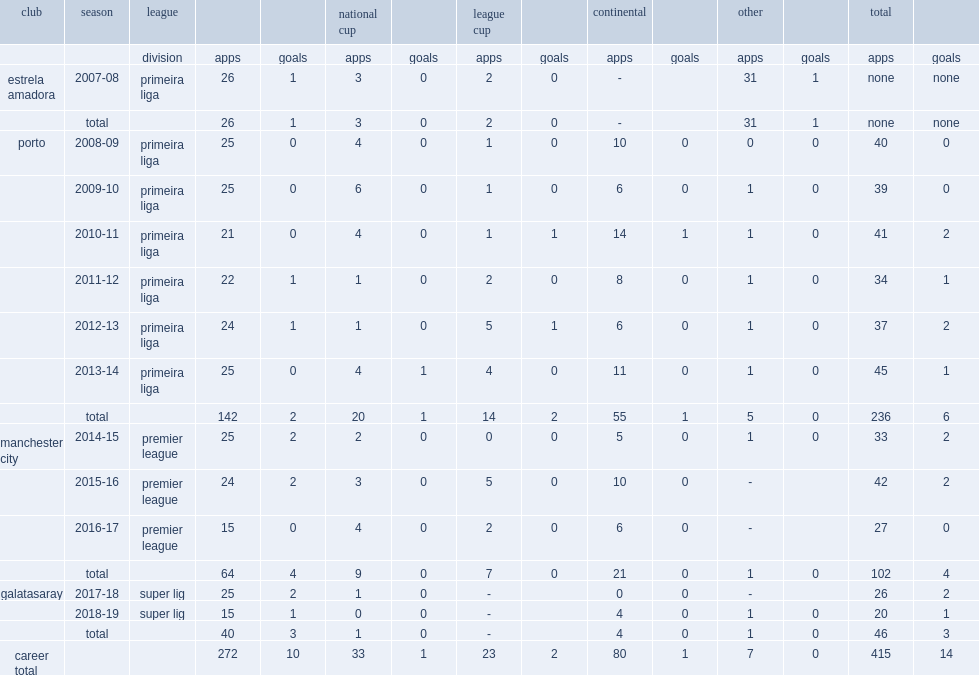Which club did fernando play for in the 2008-09 season? Porto. 